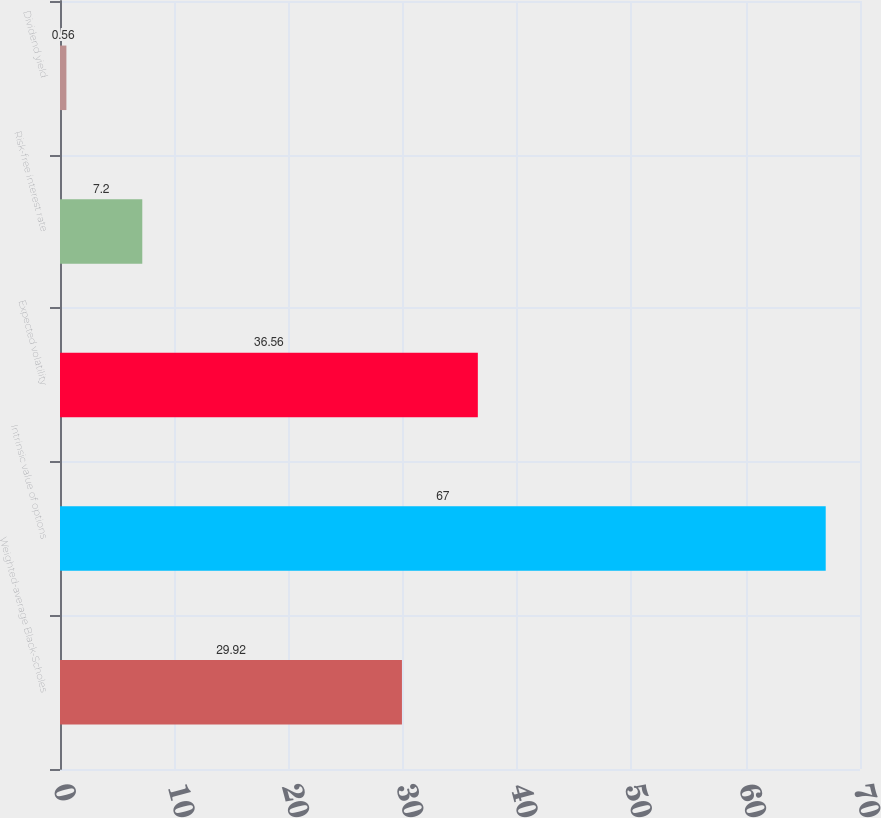<chart> <loc_0><loc_0><loc_500><loc_500><bar_chart><fcel>Weighted-average Black-Scholes<fcel>Intrinsic value of options<fcel>Expected volatility<fcel>Risk-free interest rate<fcel>Dividend yield<nl><fcel>29.92<fcel>67<fcel>36.56<fcel>7.2<fcel>0.56<nl></chart> 